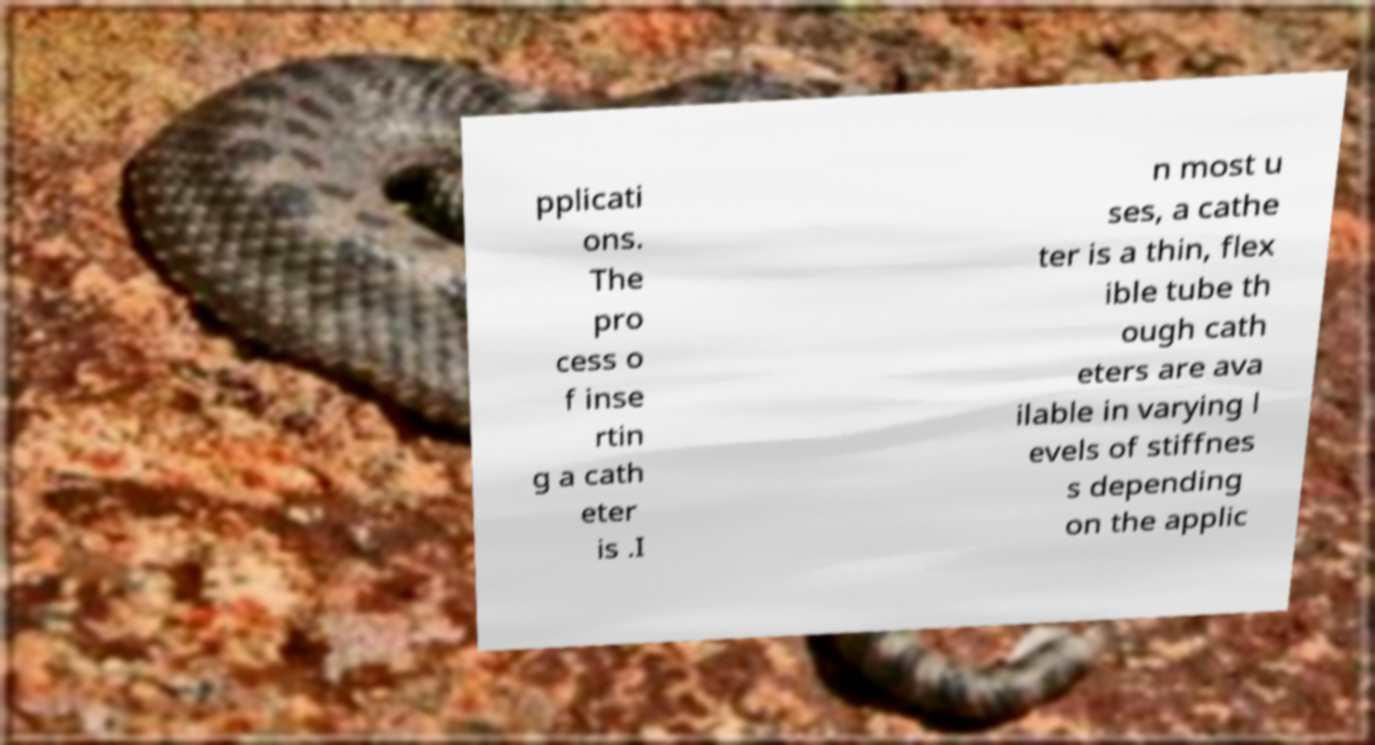Can you read and provide the text displayed in the image?This photo seems to have some interesting text. Can you extract and type it out for me? pplicati ons. The pro cess o f inse rtin g a cath eter is .I n most u ses, a cathe ter is a thin, flex ible tube th ough cath eters are ava ilable in varying l evels of stiffnes s depending on the applic 